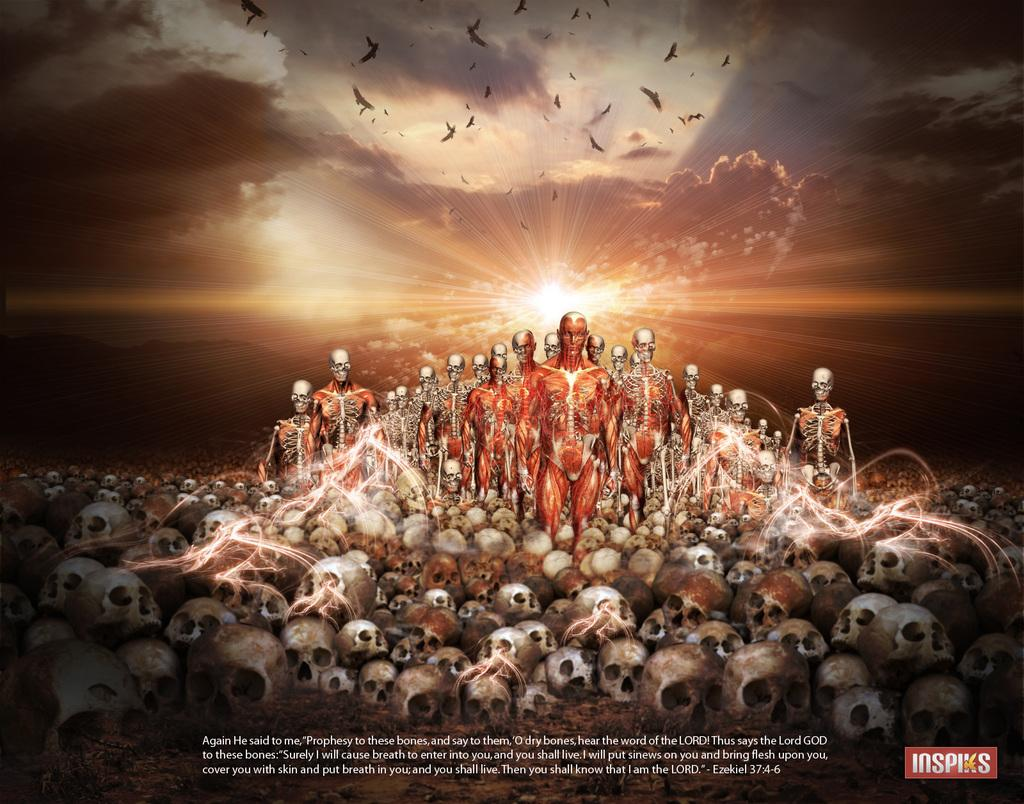<image>
Provide a brief description of the given image. A picture of muscles and bones is on an Inspiks ad. 